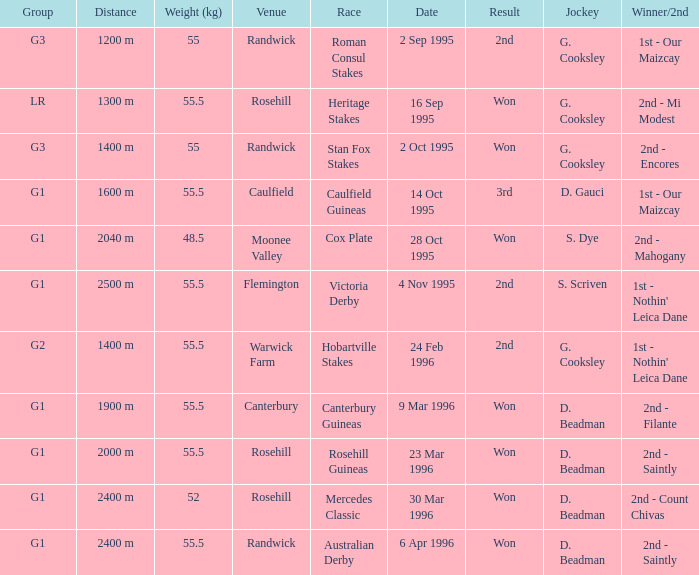What venue hosted the stan fox stakes? Randwick. 